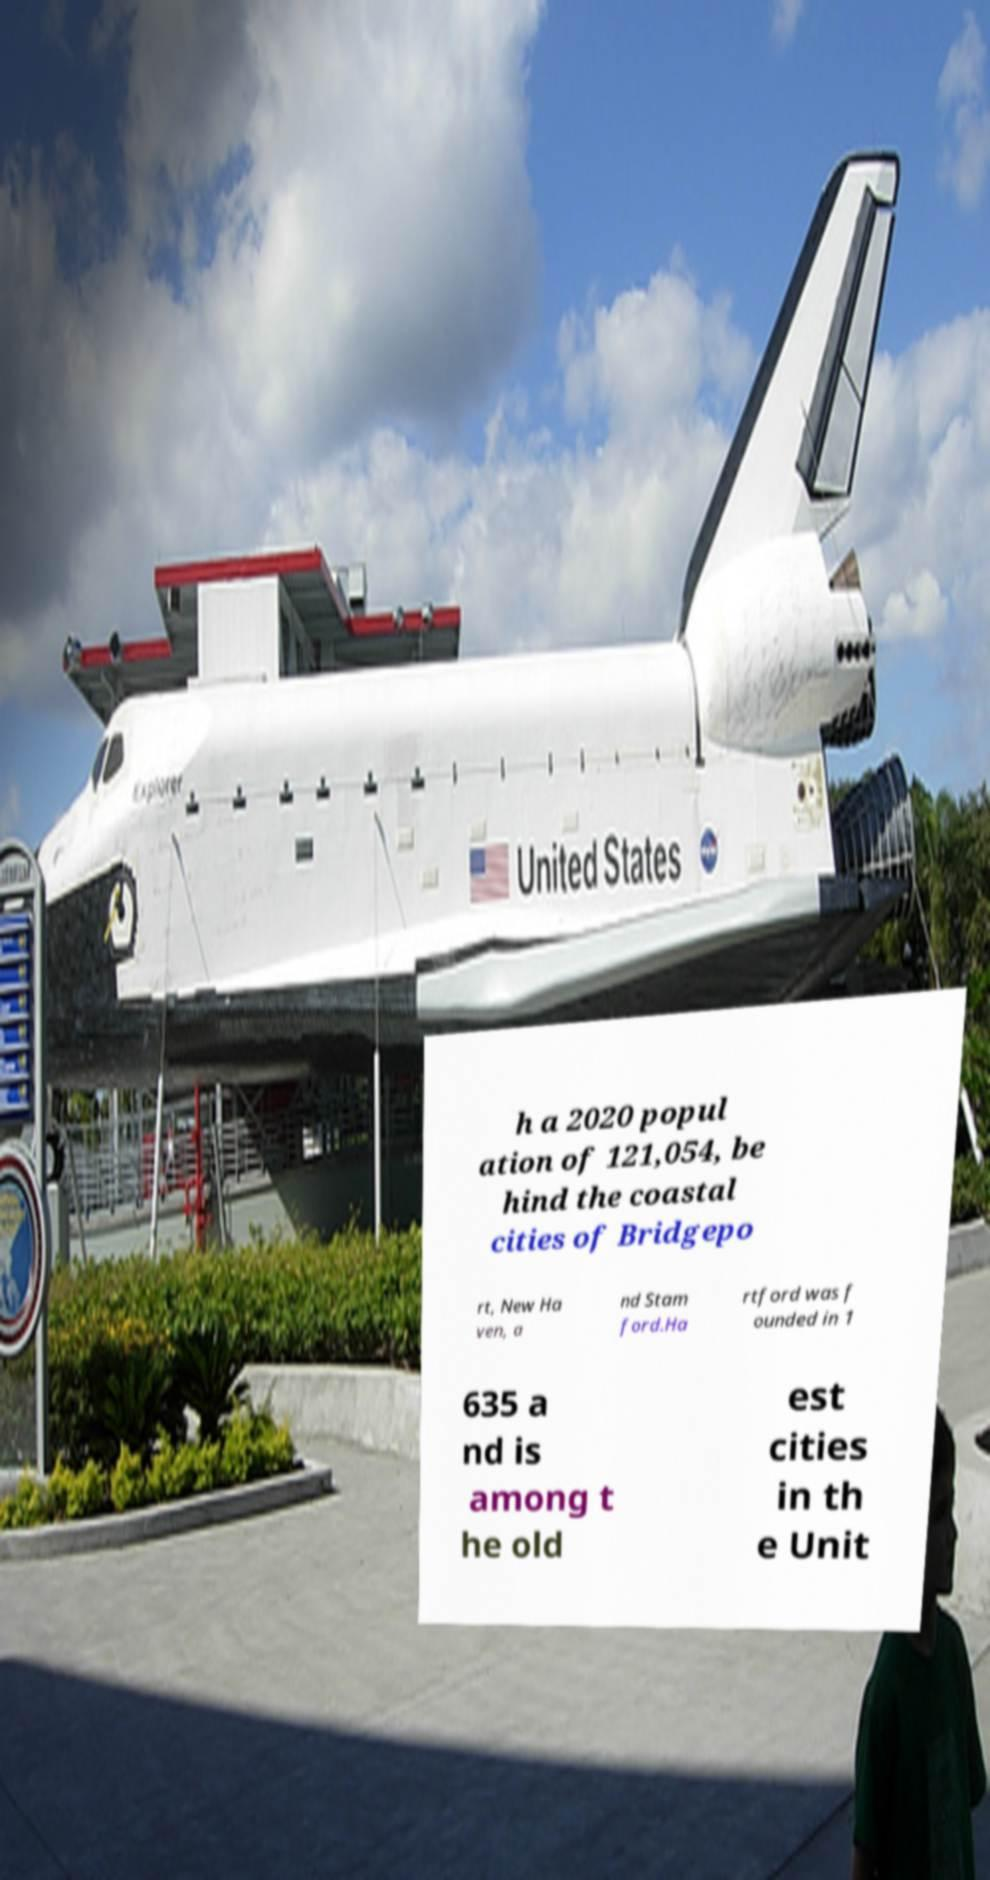There's text embedded in this image that I need extracted. Can you transcribe it verbatim? h a 2020 popul ation of 121,054, be hind the coastal cities of Bridgepo rt, New Ha ven, a nd Stam ford.Ha rtford was f ounded in 1 635 a nd is among t he old est cities in th e Unit 